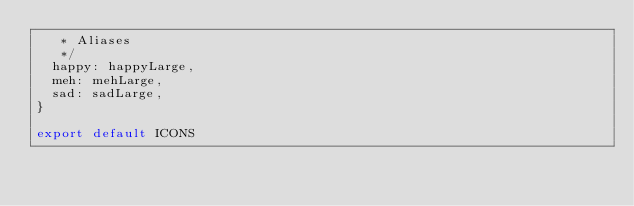<code> <loc_0><loc_0><loc_500><loc_500><_JavaScript_>   * Aliases
   */
  happy: happyLarge,
  meh: mehLarge,
  sad: sadLarge,
}

export default ICONS
</code> 